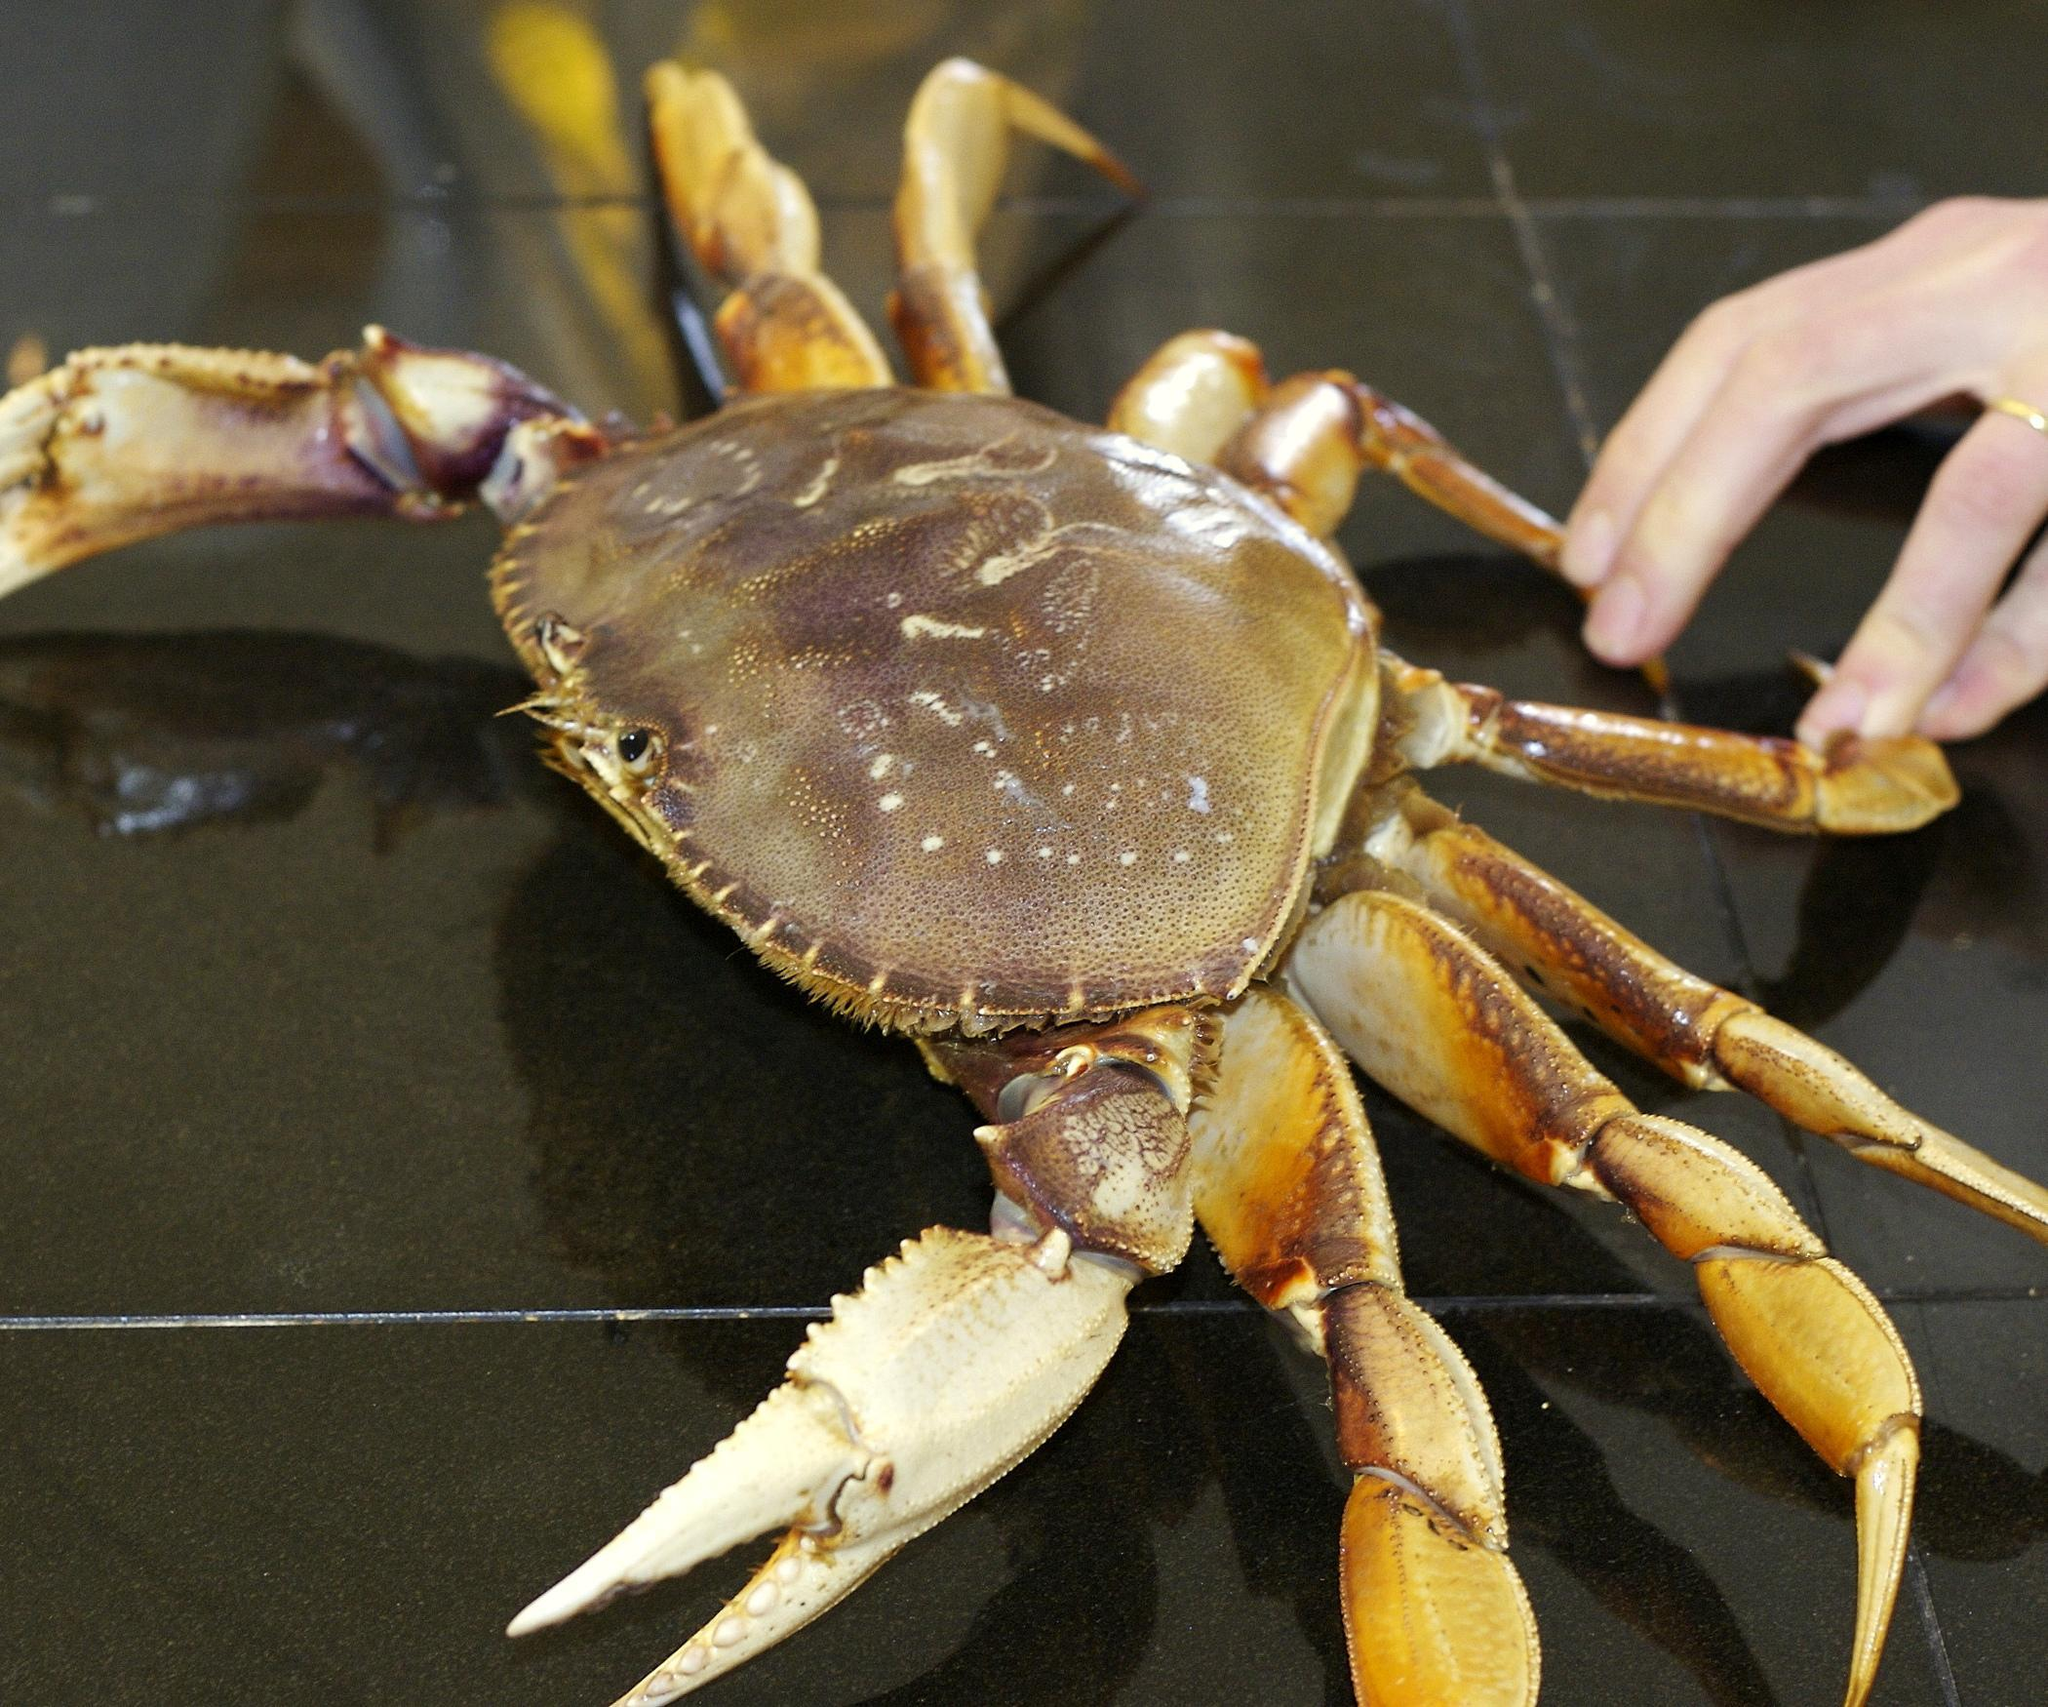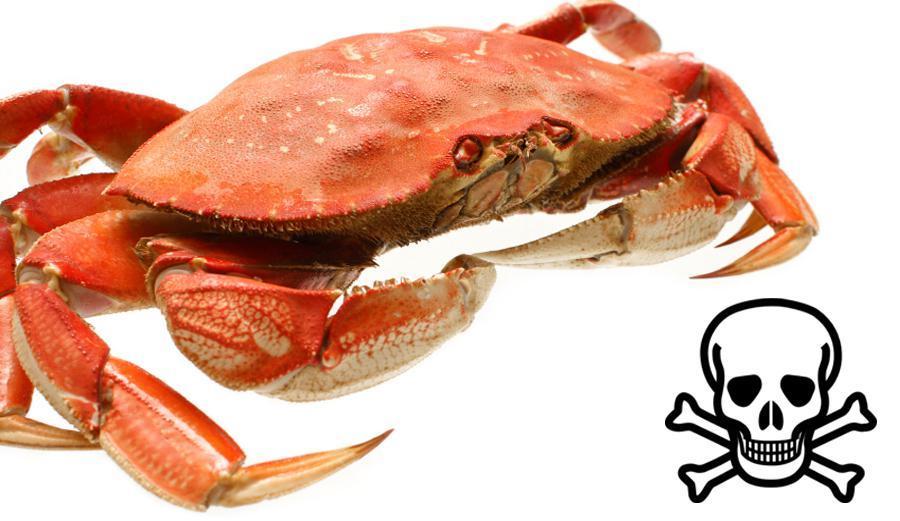The first image is the image on the left, the second image is the image on the right. Assess this claim about the two images: "Atleast one image of a crab split down the middle.". Correct or not? Answer yes or no. No. The first image is the image on the left, the second image is the image on the right. Considering the images on both sides, is "In the image on the right, a person is pulling apart the crab to expose its meat." valid? Answer yes or no. No. 